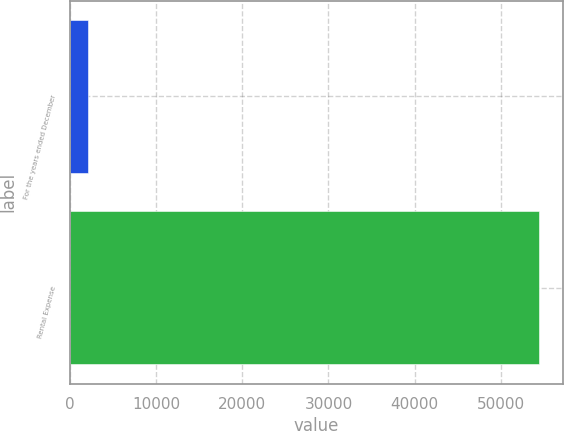Convert chart to OTSL. <chart><loc_0><loc_0><loc_500><loc_500><bar_chart><fcel>For the years ended December<fcel>Rental Expense<nl><fcel>2014<fcel>54487<nl></chart> 